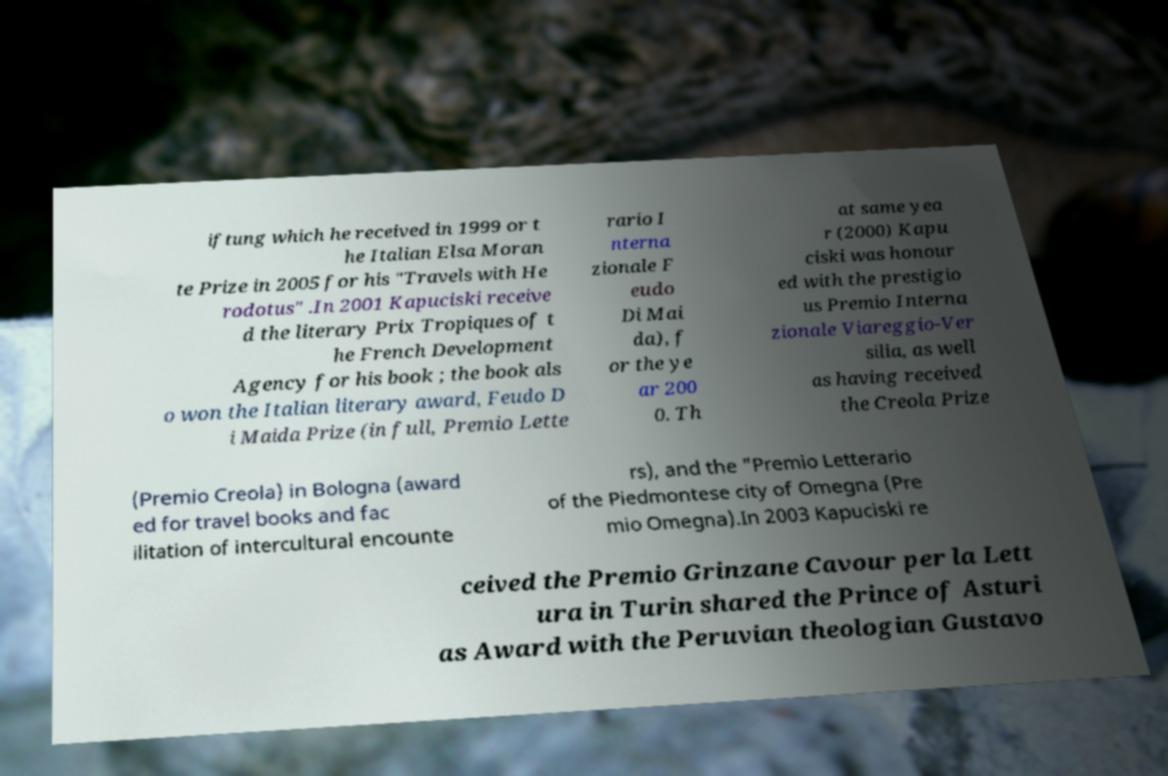What messages or text are displayed in this image? I need them in a readable, typed format. iftung which he received in 1999 or t he Italian Elsa Moran te Prize in 2005 for his "Travels with He rodotus" .In 2001 Kapuciski receive d the literary Prix Tropiques of t he French Development Agency for his book ; the book als o won the Italian literary award, Feudo D i Maida Prize (in full, Premio Lette rario I nterna zionale F eudo Di Mai da), f or the ye ar 200 0. Th at same yea r (2000) Kapu ciski was honour ed with the prestigio us Premio Interna zionale Viareggio-Ver silia, as well as having received the Creola Prize (Premio Creola) in Bologna (award ed for travel books and fac ilitation of intercultural encounte rs), and the "Premio Letterario of the Piedmontese city of Omegna (Pre mio Omegna).In 2003 Kapuciski re ceived the Premio Grinzane Cavour per la Lett ura in Turin shared the Prince of Asturi as Award with the Peruvian theologian Gustavo 